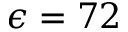<formula> <loc_0><loc_0><loc_500><loc_500>\epsilon = 7 2</formula> 